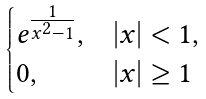Convert formula to latex. <formula><loc_0><loc_0><loc_500><loc_500>\begin{cases} e ^ { \frac { 1 } { x ^ { 2 } - 1 } } , & | x | < 1 , \\ 0 , & | x | \geq 1 \end{cases}</formula> 